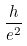Convert formula to latex. <formula><loc_0><loc_0><loc_500><loc_500>\frac { h } { e ^ { 2 } }</formula> 